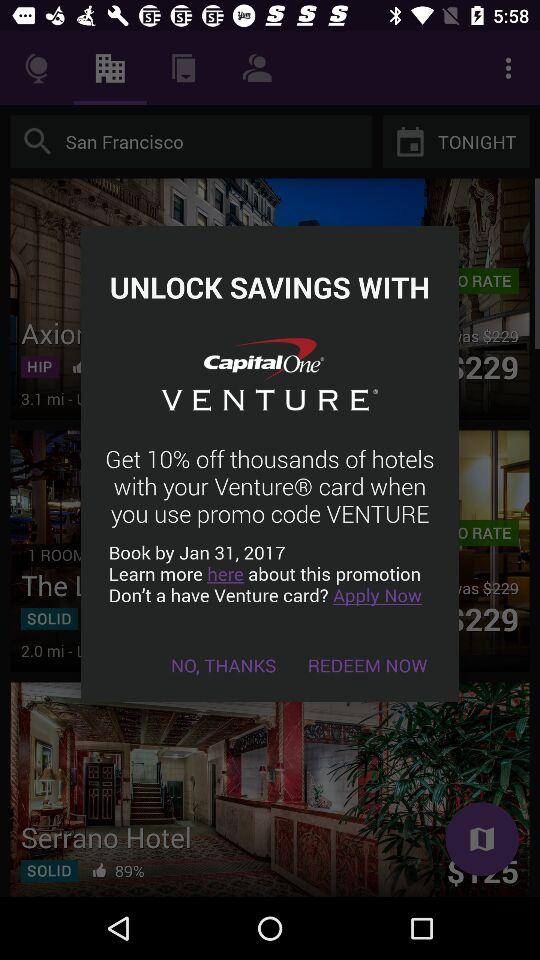How much of a discount can I get by using promo code "Venture"? You can get a discount of 10%. 